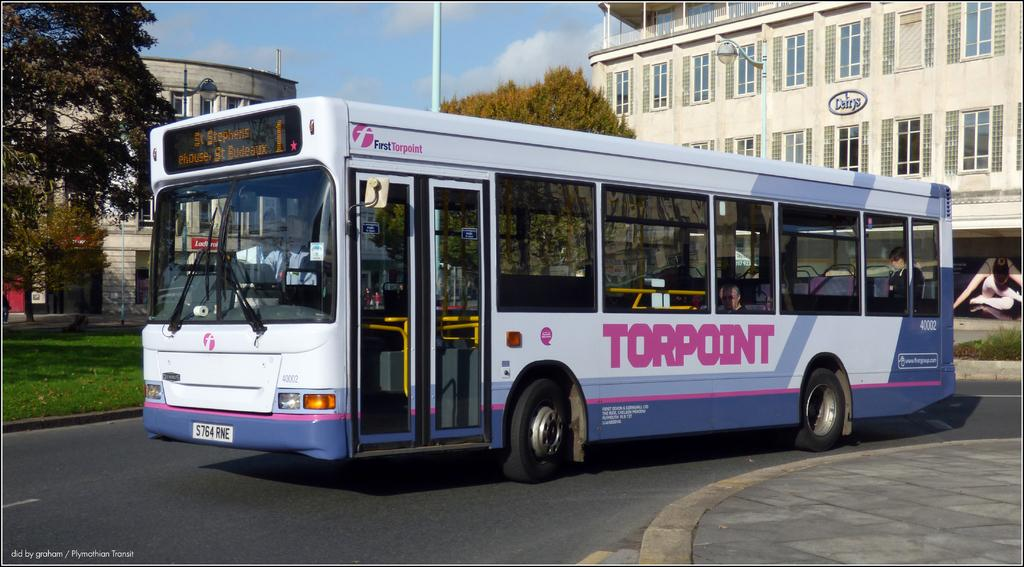Provide a one-sentence caption for the provided image. A Torpoint but that is driving in the street. 